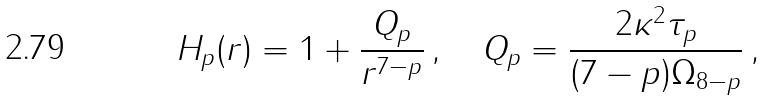<formula> <loc_0><loc_0><loc_500><loc_500>H _ { p } ( r ) = 1 + \frac { Q _ { p } } { r ^ { 7 - p } } \, , \quad Q _ { p } = \frac { 2 \kappa ^ { 2 } \tau _ { p } } { ( 7 - p ) \Omega _ { 8 - p } } \, ,</formula> 